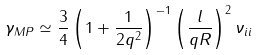<formula> <loc_0><loc_0><loc_500><loc_500>\gamma _ { M P } \simeq \frac { 3 } { 4 } \left ( 1 + \frac { 1 } { 2 q ^ { 2 } } \right ) ^ { - 1 } \left ( \frac { l } { q R } \right ) ^ { 2 } \nu _ { i i }</formula> 